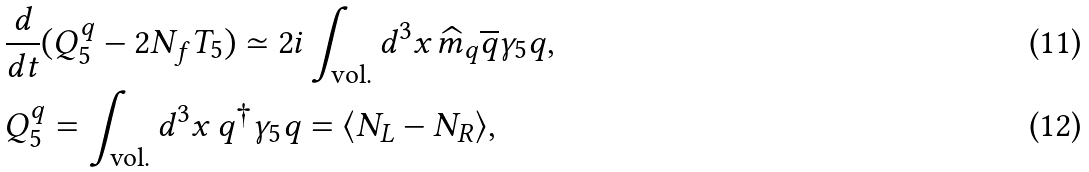<formula> <loc_0><loc_0><loc_500><loc_500>& \frac { d } { d t } ( Q _ { 5 } ^ { q } - 2 N _ { f } T _ { 5 } ) \simeq 2 i \int _ { \text {vol.} } d ^ { 3 } x \, \widehat { m } _ { q } \overline { q } \gamma _ { 5 } q , \\ & Q _ { 5 } ^ { q } = \int _ { \text {vol.} } d ^ { 3 } x \, q ^ { \dagger } \gamma _ { 5 } q = \langle N _ { L } - N _ { R } \rangle ,</formula> 